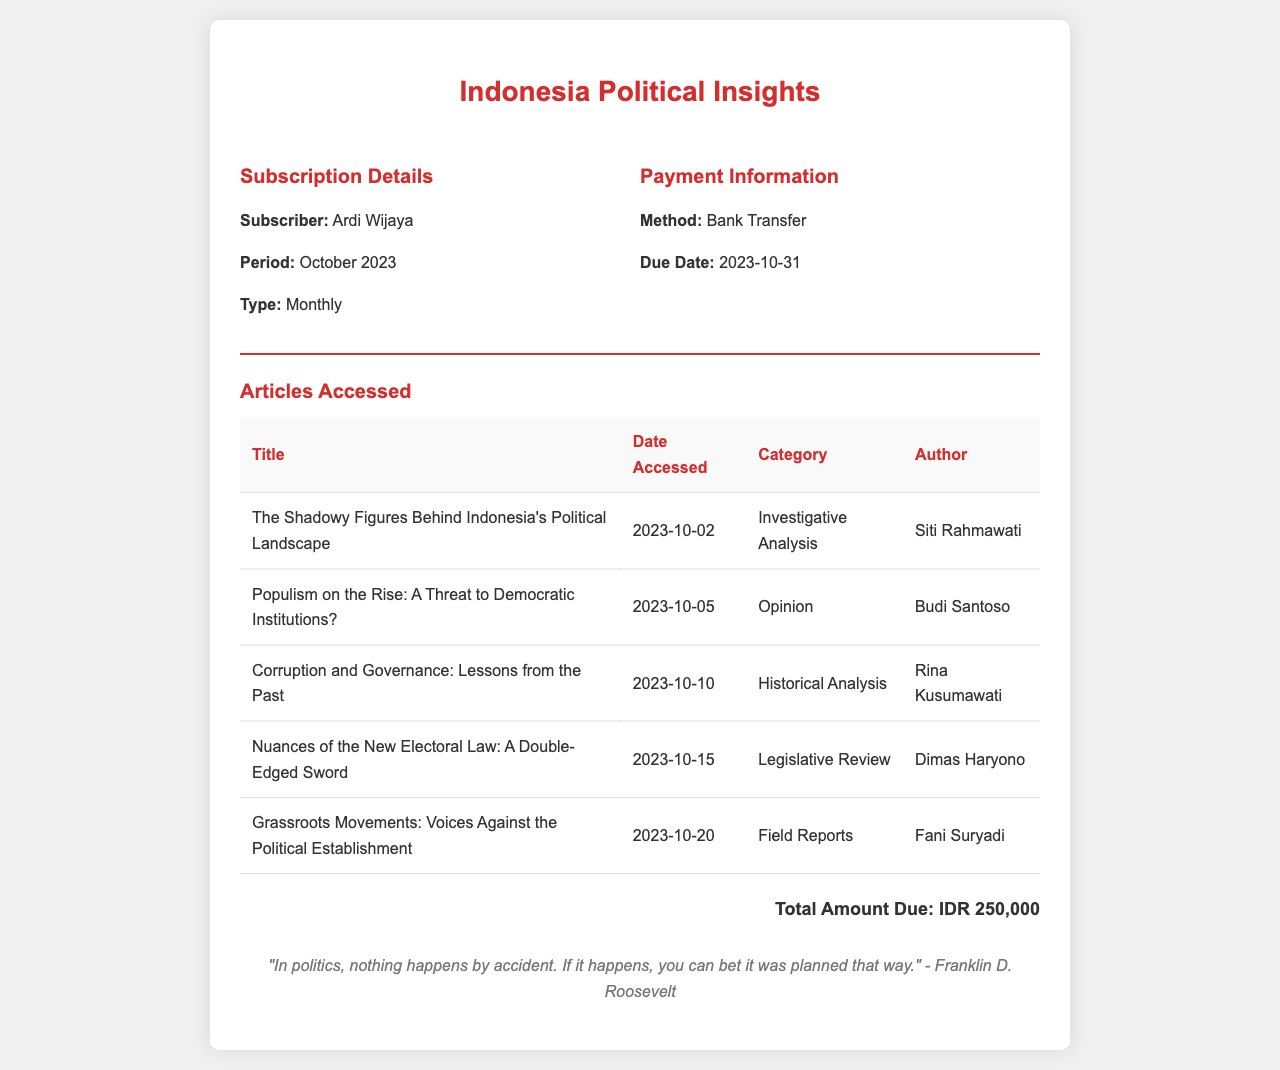What is the subscriber's name? The subscriber's name is listed in the subscription details section of the document.
Answer: Ardi Wijaya What is the subscription period? The subscription period can be found right below the subscriber's name in the subscription details.
Answer: October 2023 What is the total amount due? The total amount due is clearly specified at the bottom of the document.
Answer: IDR 250,000 When is the payment due? The due date for payment is indicated in the payment information section of the receipt.
Answer: 2023-10-31 Who authored the article titled "The Shadowy Figures Behind Indonesia's Political Landscape"? The author of the article is mentioned in the articles accessed table.
Answer: Siti Rahmawati How many articles were accessed during the subscription period? The total number of articles is the count of rows in the articles accessed table.
Answer: 5 What is the category of the article "Grassroots Movements: Voices Against the Political Establishment"? The category of the article is indicated in the articles accessed table next to the title.
Answer: Field Reports Which payment method was used? The payment method is stated in the payment information section of the receipt.
Answer: Bank Transfer What type of subscription does Ardi Wijaya have? The subscription type is detailed in the subscription information section.
Answer: Monthly 